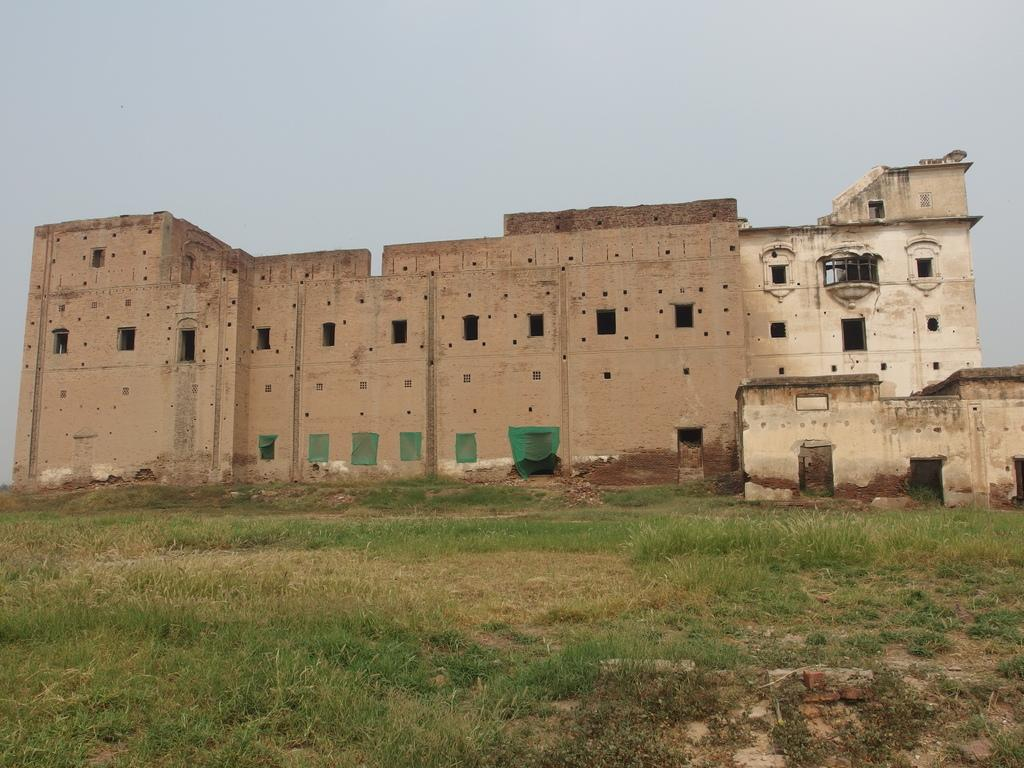What type of vegetation is present in the image? There is grass in the image. What other materials can be seen in the image? There are stones and metal rods visible in the image. What type of structures are in the image? There are buildings in the image. What features can be seen on the buildings? There are windows on the buildings. What else is present in the image? There are objects in the image. What part of the natural environment is visible in the image? The sky is visible in the image. Based on the lighting and visibility, when do you think the image was taken? The image was likely taken during the day. Can you see any necks in the image? There are no necks visible in the image. Is there any gun present in the image? There is no gun present in the image. 